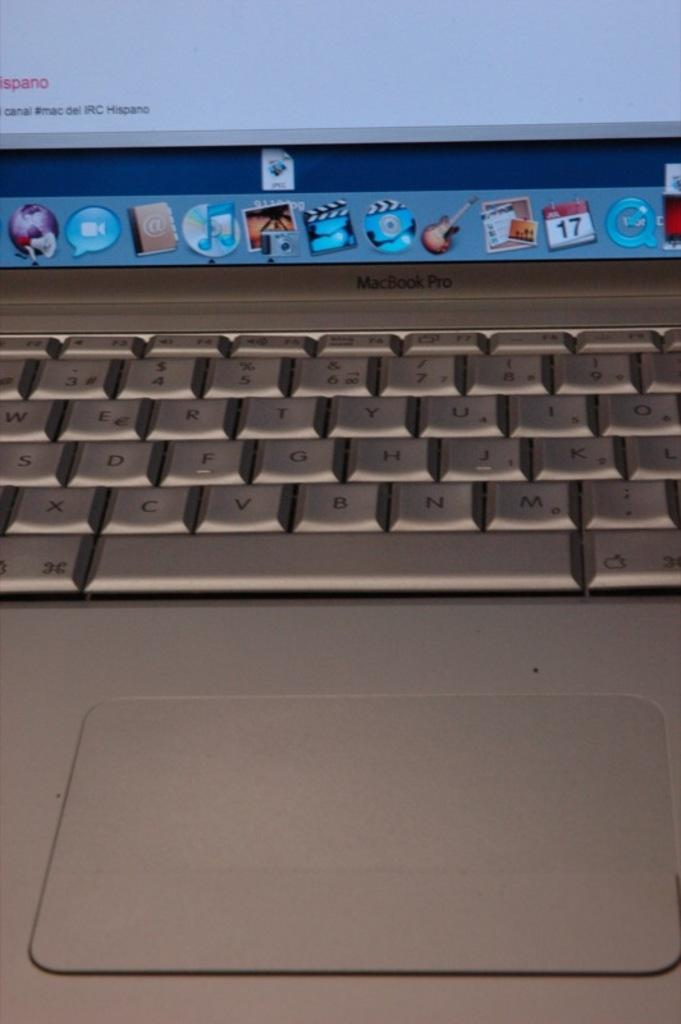<image>
Relay a brief, clear account of the picture shown. A MacBook opened to a page reading canal #mac del IRC Hispano. 